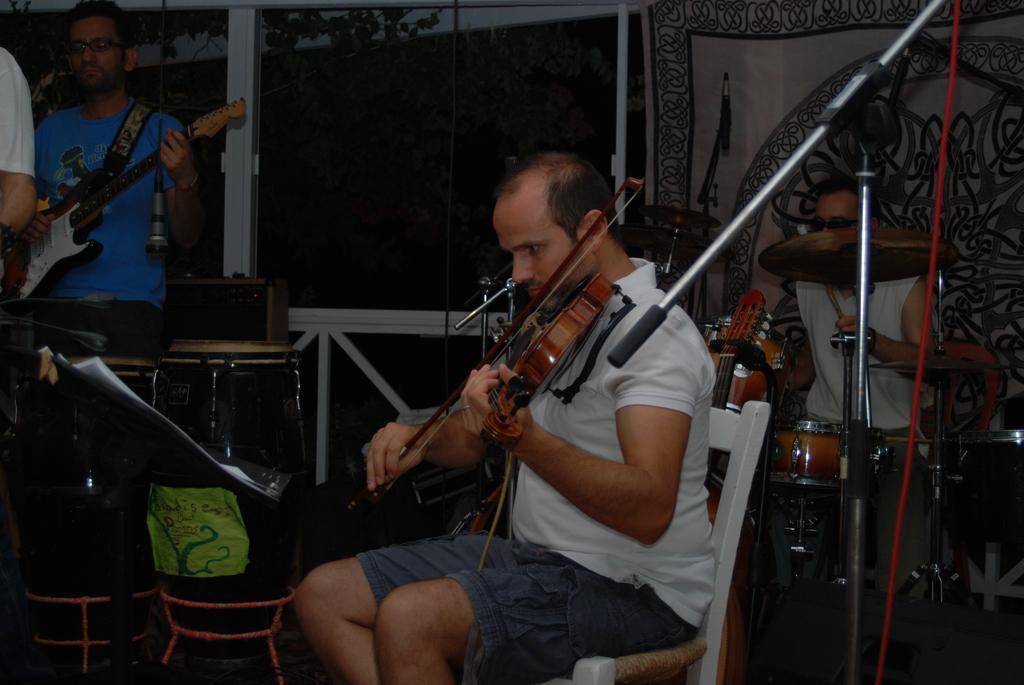In one or two sentences, can you explain what this image depicts? a person is seated on a chair and playing violin. behind him at the left a person is playing guitar. at the right back a person is playing drums. in the front there is a microphone. 